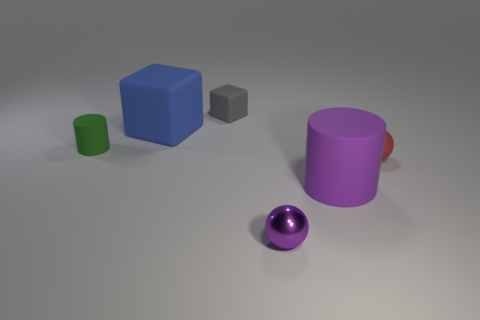What material is the big block?
Keep it short and to the point. Rubber. There is a rubber object that is both in front of the small green matte object and on the left side of the red sphere; what size is it?
Ensure brevity in your answer.  Large. What is the material of the tiny object that is the same color as the big cylinder?
Your answer should be very brief. Metal. How many brown shiny things are there?
Give a very brief answer. 0. Are there fewer tiny cubes than spheres?
Provide a succinct answer. Yes. What is the material of the cube that is the same size as the red sphere?
Give a very brief answer. Rubber. How many objects are either cyan matte things or red things?
Keep it short and to the point. 1. What number of tiny objects are both left of the large matte cube and in front of the small red thing?
Provide a succinct answer. 0. Is the number of cylinders that are to the right of the tiny cube less than the number of tiny red objects?
Provide a short and direct response. No. The red rubber object that is the same size as the metallic sphere is what shape?
Your response must be concise. Sphere. 